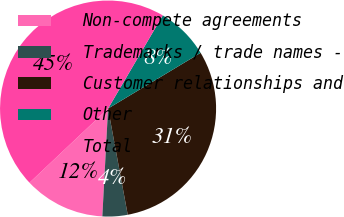<chart> <loc_0><loc_0><loc_500><loc_500><pie_chart><fcel>Non-compete agreements<fcel>Trademarks / trade names -<fcel>Customer relationships and<fcel>Other<fcel>Total<nl><fcel>12.11%<fcel>3.76%<fcel>30.71%<fcel>7.93%<fcel>45.49%<nl></chart> 